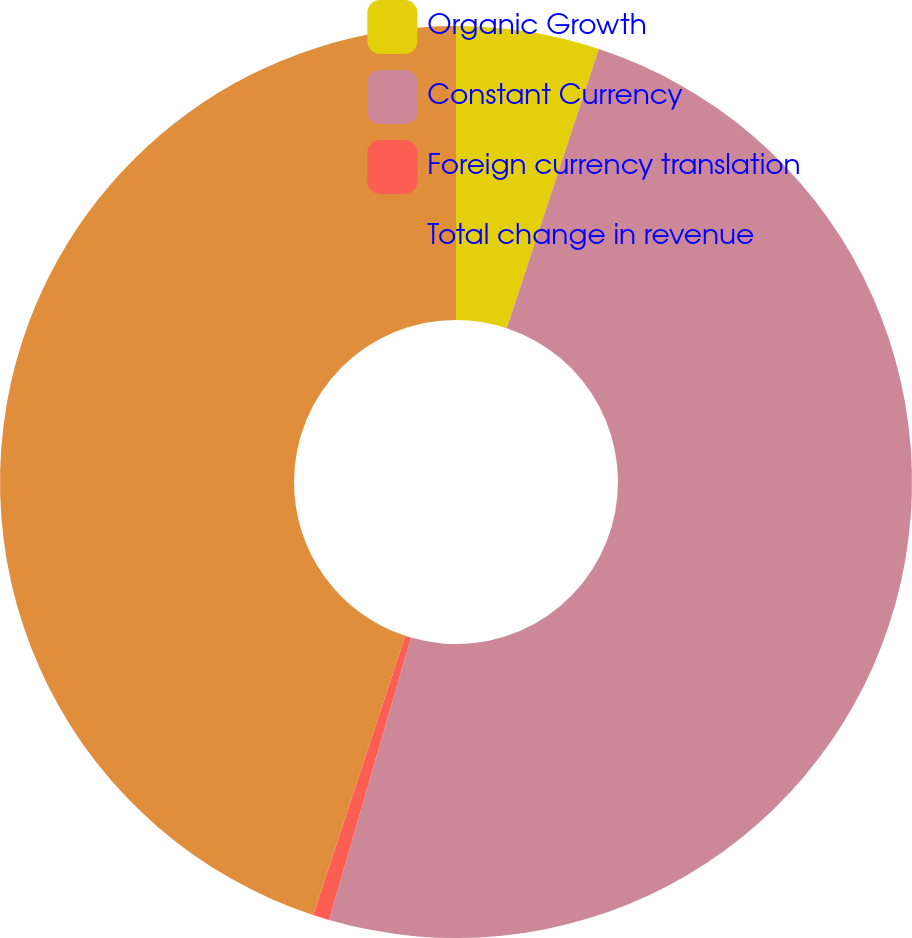<chart> <loc_0><loc_0><loc_500><loc_500><pie_chart><fcel>Organic Growth<fcel>Constant Currency<fcel>Foreign currency translation<fcel>Total change in revenue<nl><fcel>5.07%<fcel>49.42%<fcel>0.58%<fcel>44.93%<nl></chart> 